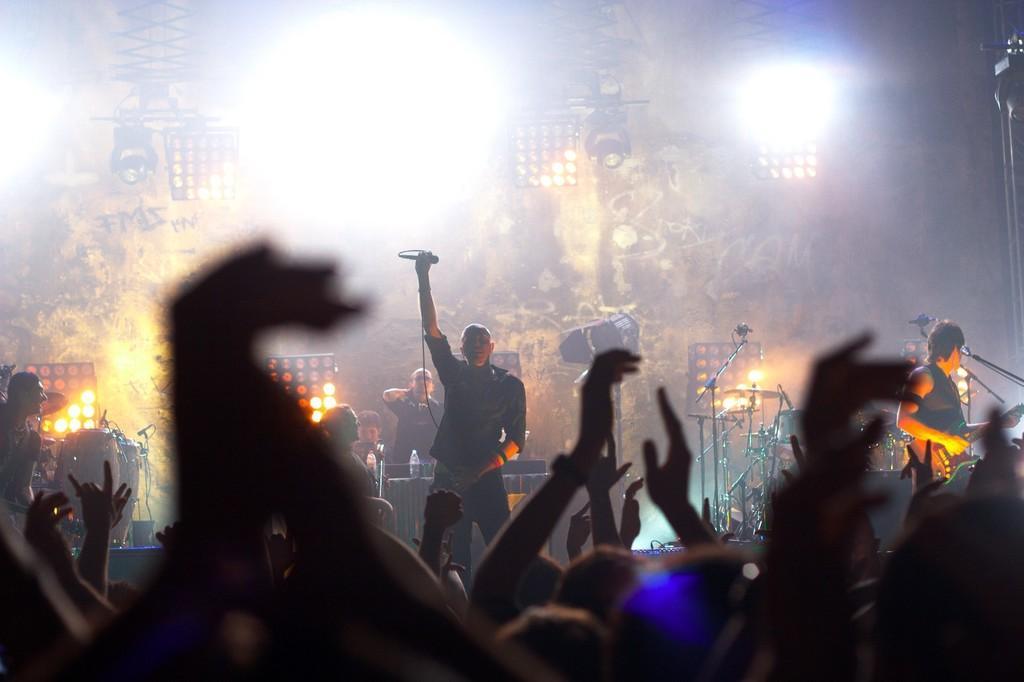Please provide a concise description of this image. In the center of the image we can see a man is standing and raising his hand and holding a mic. In the background of the image we can see the stands, musical instruments, lights, board, table. On the table we can see the bottles. On the left side of the image we can see a man is shouting. On the right side of the image we can see the mics with stands and a man is standing and holding guitar. At the bottom of the image we can see a group of people are standing and raising their hands. 